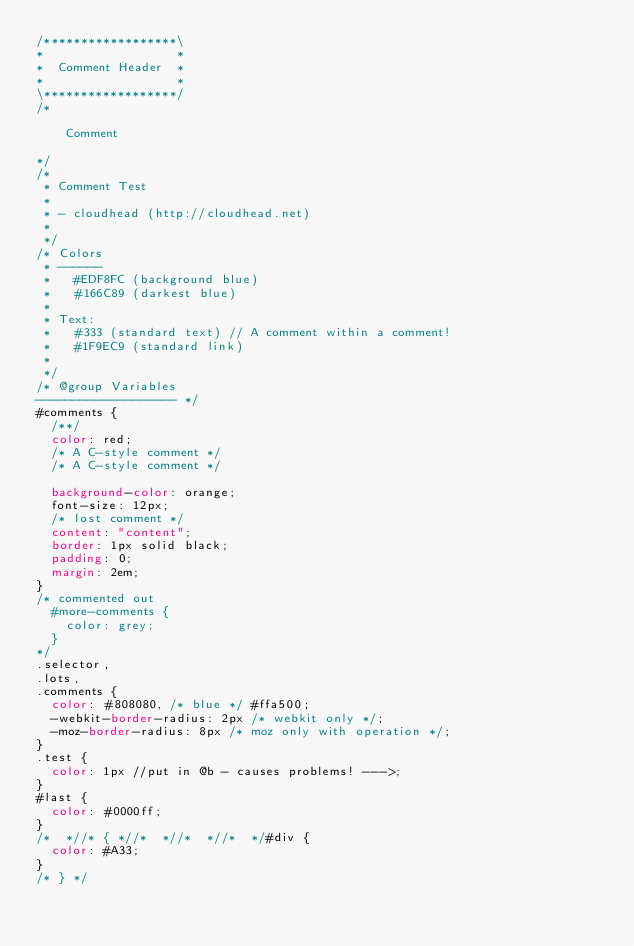<code> <loc_0><loc_0><loc_500><loc_500><_CSS_>/******************\
*                  *
*  Comment Header  *
*                  *
\******************/
/*

    Comment

*/
/*
 * Comment Test
 *
 * - cloudhead (http://cloudhead.net)
 *
 */
/* Colors
 * ------
 *   #EDF8FC (background blue)
 *   #166C89 (darkest blue)
 *
 * Text:
 *   #333 (standard text) // A comment within a comment!
 *   #1F9EC9 (standard link)
 *
 */
/* @group Variables
------------------- */
#comments {
  /**/
  color: red;
  /* A C-style comment */
  /* A C-style comment */

  background-color: orange;
  font-size: 12px;
  /* lost comment */
  content: "content";
  border: 1px solid black;
  padding: 0;
  margin: 2em;
}
/* commented out
  #more-comments {
    color: grey;
  }
*/
.selector,
.lots,
.comments {
  color: #808080, /* blue */ #ffa500;
  -webkit-border-radius: 2px /* webkit only */;
  -moz-border-radius: 8px /* moz only with operation */;
}
.test {
  color: 1px //put in @b - causes problems! --->;
}
#last {
  color: #0000ff;
}
/*  *//* { *//*  *//*  *//*  */#div {
  color: #A33;
}
/* } */
</code> 